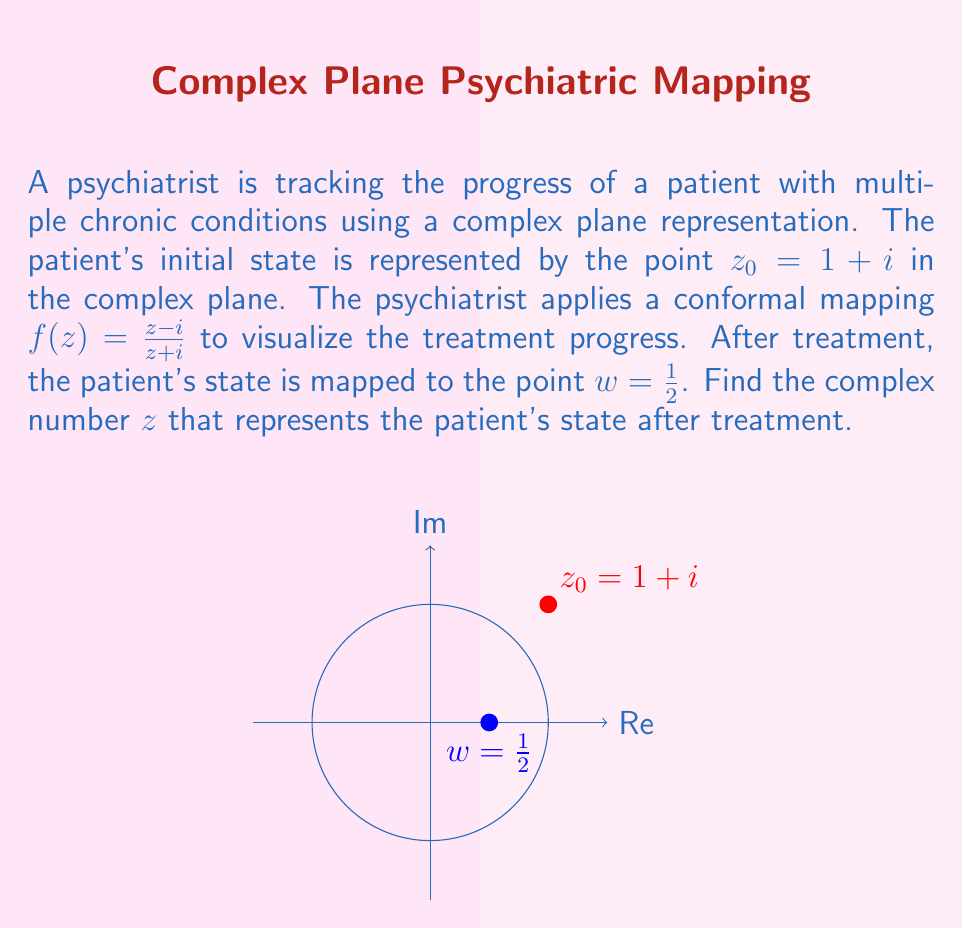What is the answer to this math problem? Let's approach this step-by-step:

1) We are given that $f(z) = \frac{z-i}{z+i}$ and $f(z) = w = \frac{1}{2}$

2) To find $z$, we need to solve the equation:

   $$\frac{z-i}{z+i} = \frac{1}{2}$$

3) Cross-multiply:
   
   $$(z-i) = \frac{1}{2}(z+i)$$

4) Distribute on the right side:
   
   $$z-i = \frac{1}{2}z + \frac{1}{2}i$$

5) Subtract $\frac{1}{2}z$ from both sides:
   
   $$\frac{1}{2}z - i = \frac{1}{2}i$$

6) Add $i$ to both sides:
   
   $$\frac{1}{2}z = \frac{3}{2}i$$

7) Multiply both sides by 2:
   
   $$z = 3i$$

8) Therefore, the patient's state after treatment is represented by the complex number $z = 3i$.

This means that the patient's condition has improved along the imaginary axis, which could represent an improvement in emotional or psychological aspects of their health.
Answer: $3i$ 